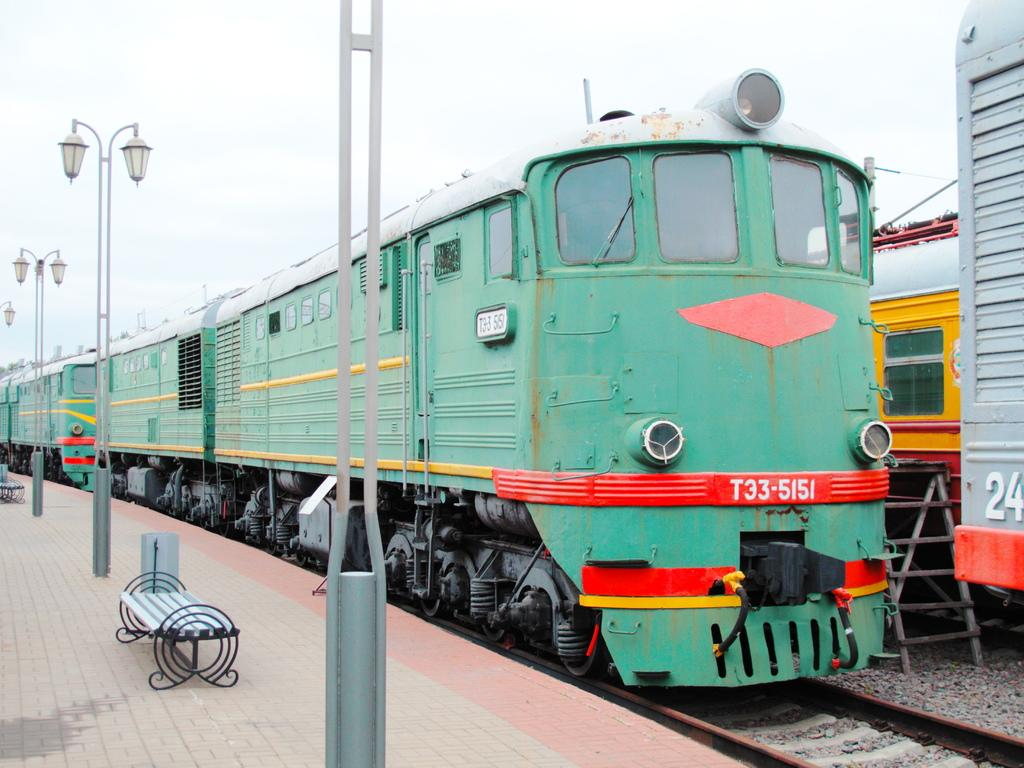<image>
Render a clear and concise summary of the photo. A green train number T33-5151 is pulling into the station. 